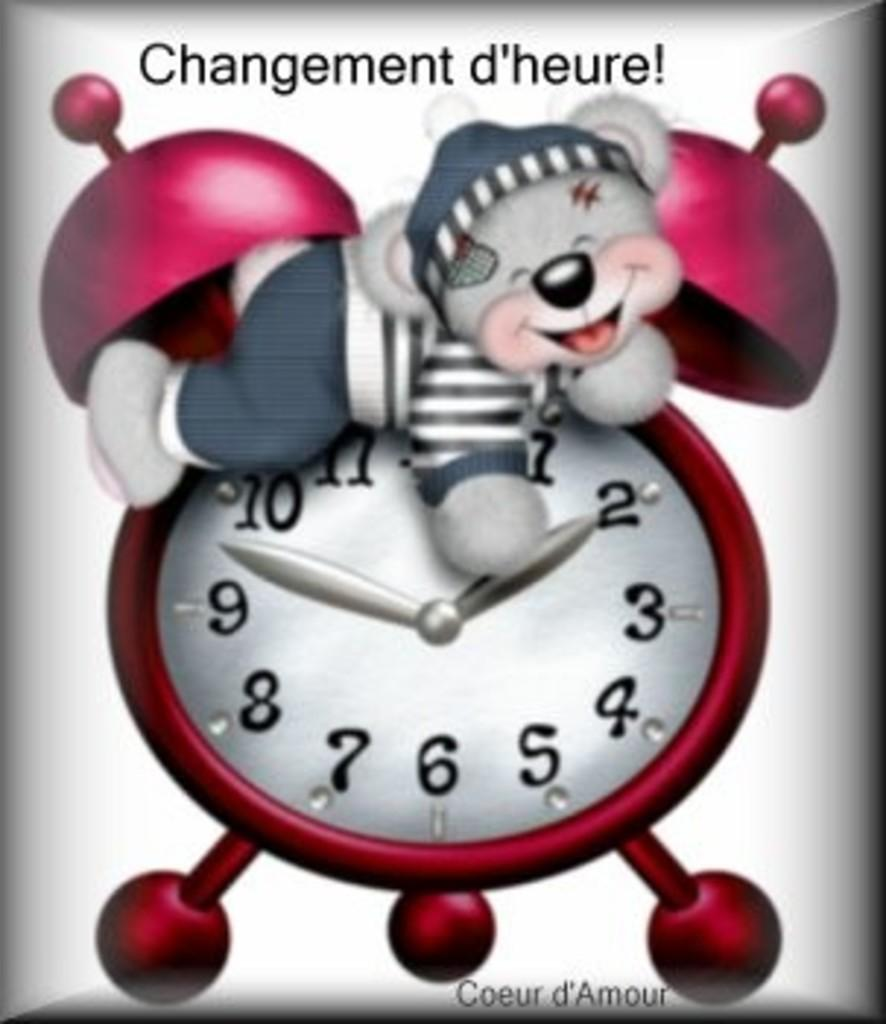<image>
Write a terse but informative summary of the picture. a bear is sitting on a clock that says Changement d'heure 